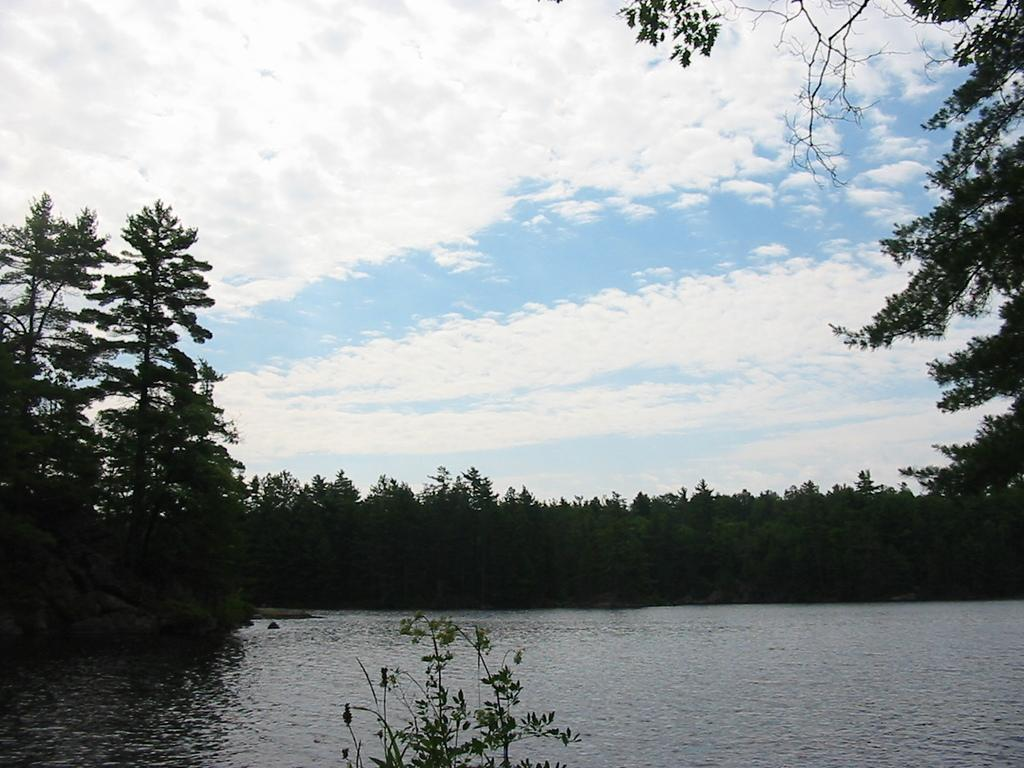What type of view is shown in the image? The image is an outside view. What can be seen at the bottom of the image? There is water visible at the bottom of the image. What is located near the water? There is a plant near the water. What is visible in the background of the image? There are many trees in the background of the image. What is visible at the top of the image? The sky is visible at the top of the image. What can be observed in the sky? Clouds are present in the sky. What type of flower is being used as a centerpiece for the feast in the image? There is no feast or flower present in the image; it shows an outside view with water, a plant, trees, and a sky with clouds. Is there a baseball game happening in the background of the image? There is no baseball game or any reference to sports in the image; it shows an outside view with water, a plant, trees, and a sky with clouds. 